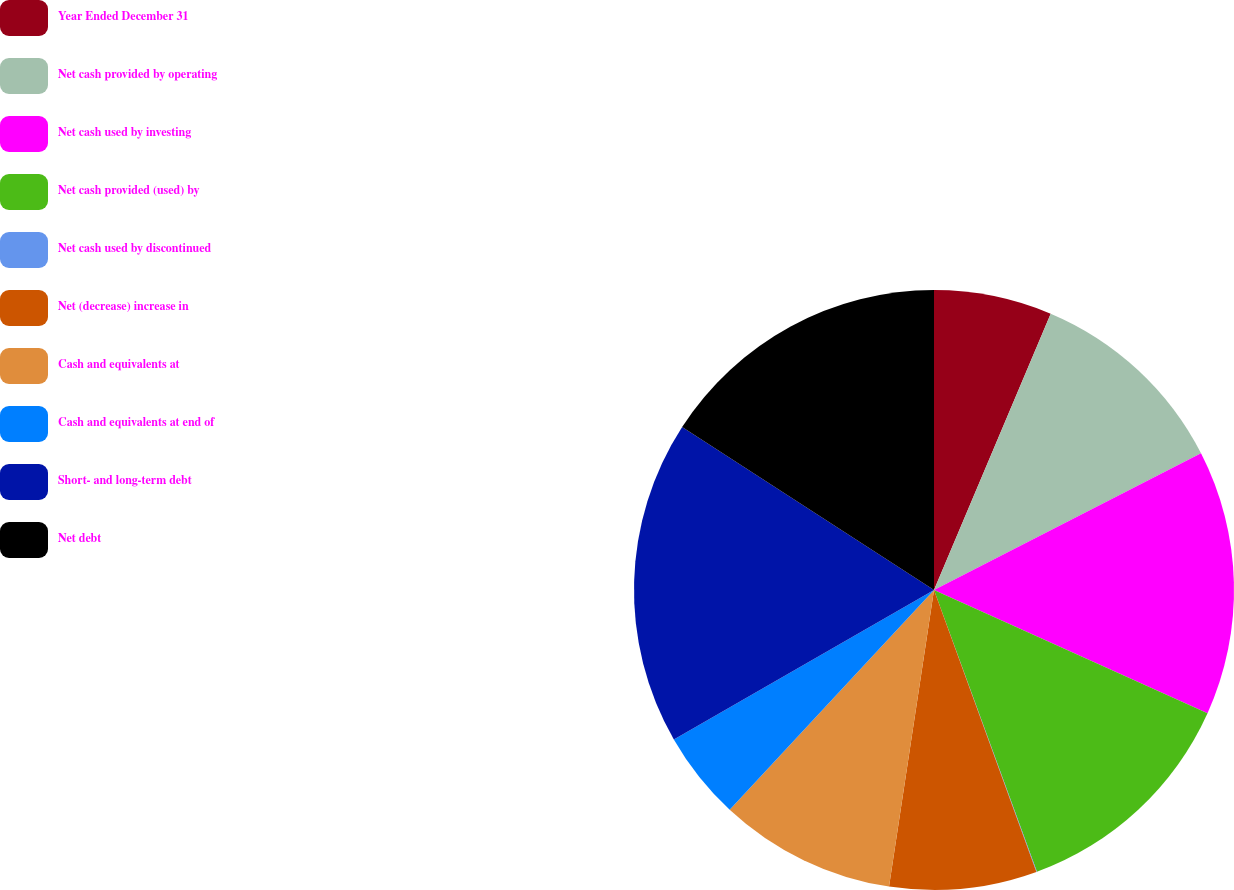<chart> <loc_0><loc_0><loc_500><loc_500><pie_chart><fcel>Year Ended December 31<fcel>Net cash provided by operating<fcel>Net cash used by investing<fcel>Net cash provided (used) by<fcel>Net cash used by discontinued<fcel>Net (decrease) increase in<fcel>Cash and equivalents at<fcel>Cash and equivalents at end of<fcel>Short- and long-term debt<fcel>Net debt<nl><fcel>6.36%<fcel>11.11%<fcel>14.27%<fcel>12.69%<fcel>0.03%<fcel>7.94%<fcel>9.53%<fcel>4.78%<fcel>17.44%<fcel>15.86%<nl></chart> 